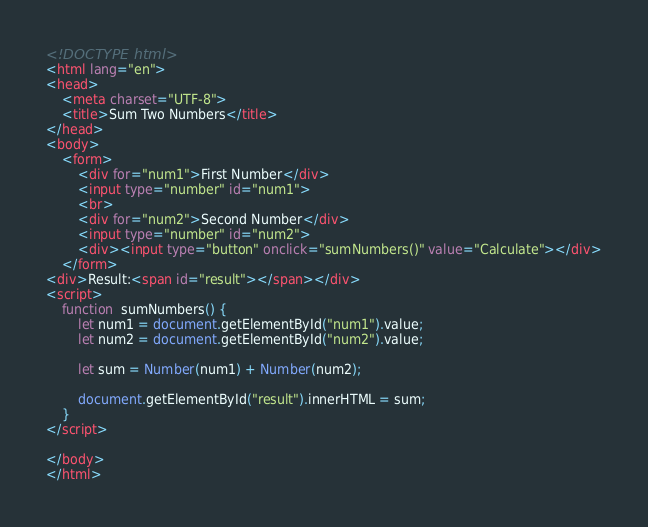Convert code to text. <code><loc_0><loc_0><loc_500><loc_500><_HTML_><!DOCTYPE html>
<html lang="en">
<head>
    <meta charset="UTF-8">
    <title>Sum Two Numbers</title>
</head>
<body>
    <form>
        <div for="num1">First Number</div>
        <input type="number" id="num1">
        <br>
        <div for="num2">Second Number</div>
        <input type="number" id="num2">
        <div><input type="button" onclick="sumNumbers()" value="Calculate"></div>
    </form>
<div>Result:<span id="result"></span></div>
<script>
    function  sumNumbers() {
        let num1 = document.getElementById("num1").value;
        let num2 = document.getElementById("num2").value;

        let sum = Number(num1) + Number(num2);

        document.getElementById("result").innerHTML = sum;
    }
</script>

</body>
</html></code> 